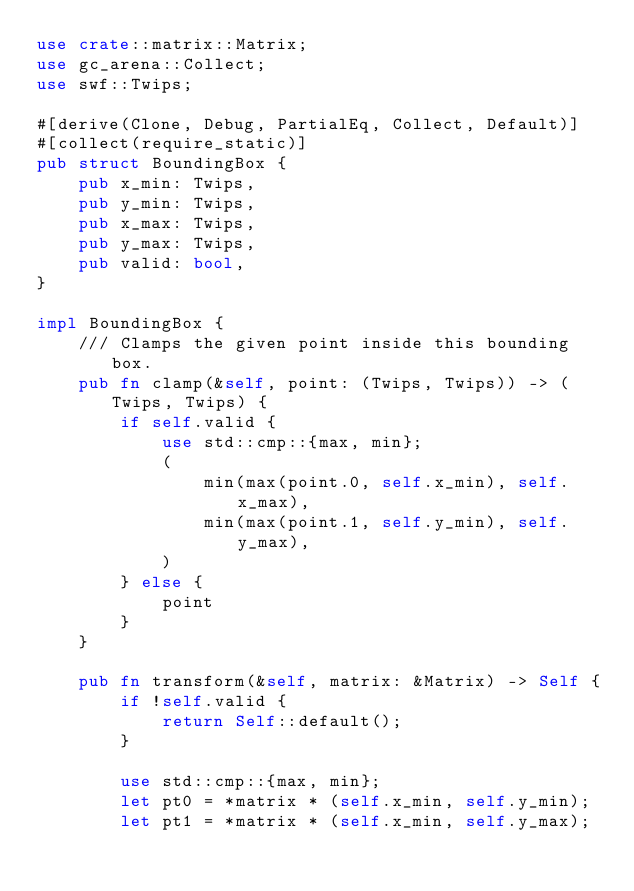<code> <loc_0><loc_0><loc_500><loc_500><_Rust_>use crate::matrix::Matrix;
use gc_arena::Collect;
use swf::Twips;

#[derive(Clone, Debug, PartialEq, Collect, Default)]
#[collect(require_static)]
pub struct BoundingBox {
    pub x_min: Twips,
    pub y_min: Twips,
    pub x_max: Twips,
    pub y_max: Twips,
    pub valid: bool,
}

impl BoundingBox {
    /// Clamps the given point inside this bounding box.
    pub fn clamp(&self, point: (Twips, Twips)) -> (Twips, Twips) {
        if self.valid {
            use std::cmp::{max, min};
            (
                min(max(point.0, self.x_min), self.x_max),
                min(max(point.1, self.y_min), self.y_max),
            )
        } else {
            point
        }
    }

    pub fn transform(&self, matrix: &Matrix) -> Self {
        if !self.valid {
            return Self::default();
        }

        use std::cmp::{max, min};
        let pt0 = *matrix * (self.x_min, self.y_min);
        let pt1 = *matrix * (self.x_min, self.y_max);</code> 